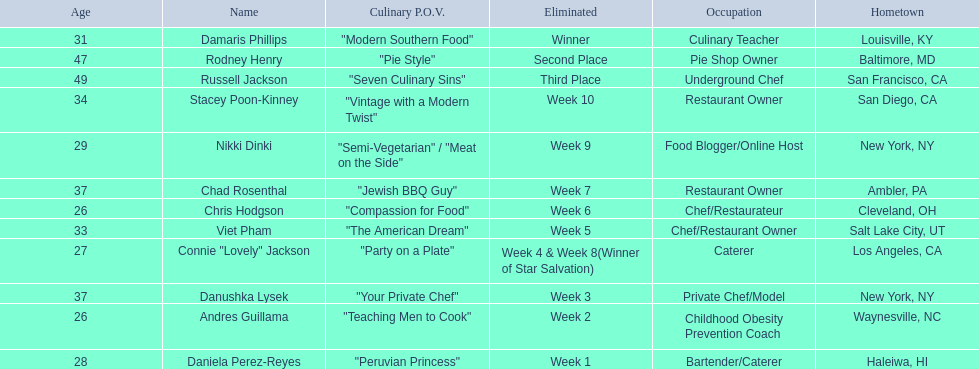Who are all of the people listed? Damaris Phillips, Rodney Henry, Russell Jackson, Stacey Poon-Kinney, Nikki Dinki, Chad Rosenthal, Chris Hodgson, Viet Pham, Connie "Lovely" Jackson, Danushka Lysek, Andres Guillama, Daniela Perez-Reyes. How old are they? 31, 47, 49, 34, 29, 37, 26, 33, 27, 37, 26, 28. Along with chris hodgson, which other person is 26 years old? Andres Guillama. 